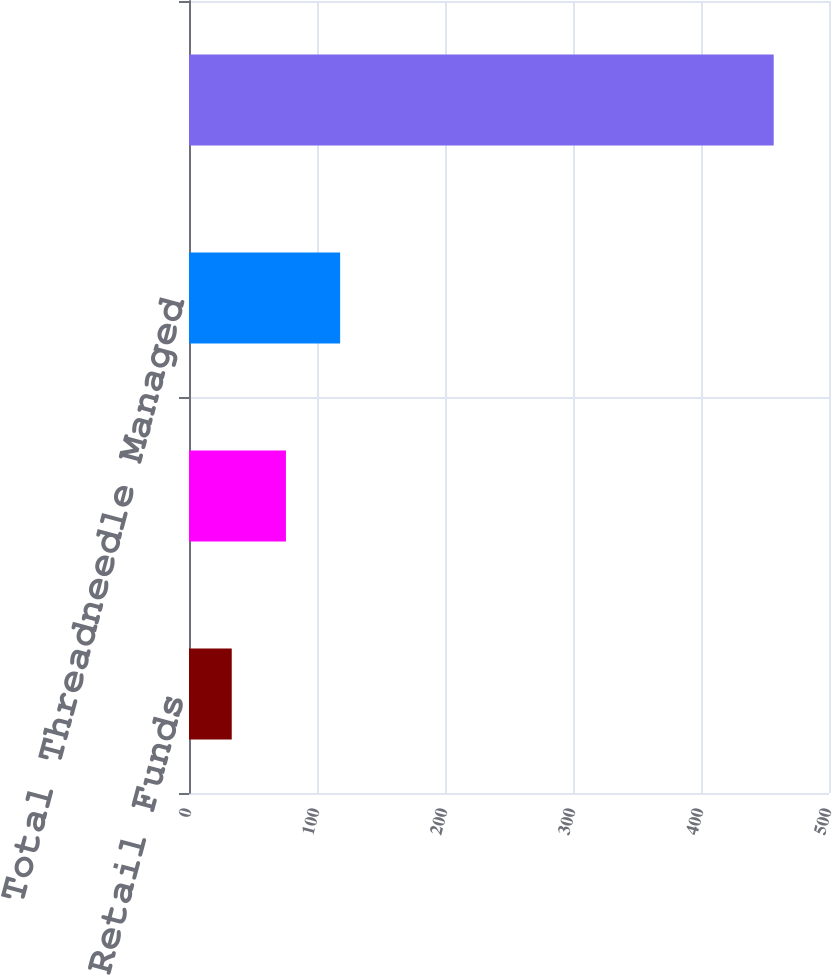Convert chart to OTSL. <chart><loc_0><loc_0><loc_500><loc_500><bar_chart><fcel>Retail Funds<fcel>Institutional Funds<fcel>Total Threadneedle Managed<fcel>Total Managed Assets<nl><fcel>33.4<fcel>75.74<fcel>118.08<fcel>456.8<nl></chart> 